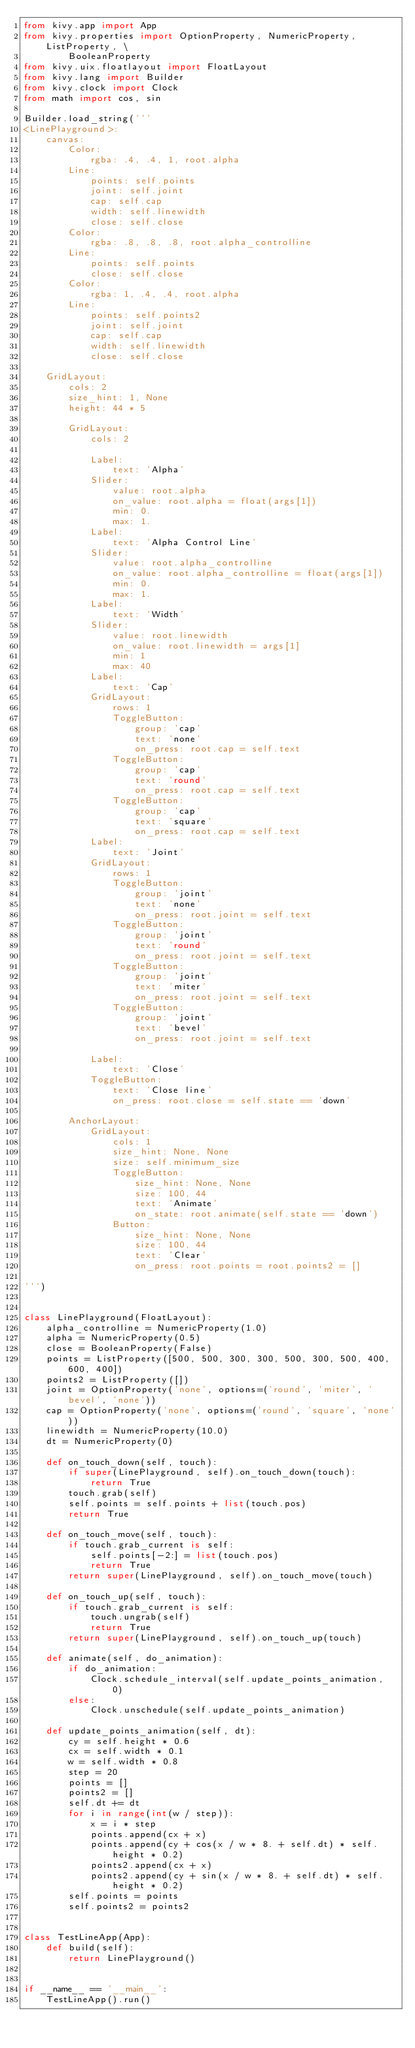<code> <loc_0><loc_0><loc_500><loc_500><_Python_>from kivy.app import App
from kivy.properties import OptionProperty, NumericProperty, ListProperty, \
        BooleanProperty
from kivy.uix.floatlayout import FloatLayout
from kivy.lang import Builder
from kivy.clock import Clock
from math import cos, sin

Builder.load_string('''
<LinePlayground>:
    canvas:
        Color:
            rgba: .4, .4, 1, root.alpha
        Line:
            points: self.points
            joint: self.joint
            cap: self.cap
            width: self.linewidth
            close: self.close
        Color:
            rgba: .8, .8, .8, root.alpha_controlline
        Line:
            points: self.points
            close: self.close
        Color:
            rgba: 1, .4, .4, root.alpha
        Line:
            points: self.points2
            joint: self.joint
            cap: self.cap
            width: self.linewidth
            close: self.close

    GridLayout:
        cols: 2
        size_hint: 1, None
        height: 44 * 5

        GridLayout:
            cols: 2

            Label:
                text: 'Alpha'
            Slider:
                value: root.alpha
                on_value: root.alpha = float(args[1])
                min: 0.
                max: 1.
            Label:
                text: 'Alpha Control Line'
            Slider:
                value: root.alpha_controlline
                on_value: root.alpha_controlline = float(args[1])
                min: 0.
                max: 1.
            Label:
                text: 'Width'
            Slider:
                value: root.linewidth
                on_value: root.linewidth = args[1]
                min: 1
                max: 40
            Label:
                text: 'Cap'
            GridLayout:
                rows: 1
                ToggleButton:
                    group: 'cap'
                    text: 'none'
                    on_press: root.cap = self.text
                ToggleButton:
                    group: 'cap'
                    text: 'round'
                    on_press: root.cap = self.text
                ToggleButton:
                    group: 'cap'
                    text: 'square'
                    on_press: root.cap = self.text
            Label:
                text: 'Joint'
            GridLayout:
                rows: 1
                ToggleButton:
                    group: 'joint'
                    text: 'none'
                    on_press: root.joint = self.text
                ToggleButton:
                    group: 'joint'
                    text: 'round'
                    on_press: root.joint = self.text
                ToggleButton:
                    group: 'joint'
                    text: 'miter'
                    on_press: root.joint = self.text
                ToggleButton:
                    group: 'joint'
                    text: 'bevel'
                    on_press: root.joint = self.text

            Label:
                text: 'Close'
            ToggleButton:
                text: 'Close line'
                on_press: root.close = self.state == 'down'

        AnchorLayout:
            GridLayout:
                cols: 1
                size_hint: None, None
                size: self.minimum_size
                ToggleButton:
                    size_hint: None, None
                    size: 100, 44
                    text: 'Animate'
                    on_state: root.animate(self.state == 'down')
                Button:
                    size_hint: None, None
                    size: 100, 44
                    text: 'Clear'
                    on_press: root.points = root.points2 = []

''')


class LinePlayground(FloatLayout):
    alpha_controlline = NumericProperty(1.0)
    alpha = NumericProperty(0.5)
    close = BooleanProperty(False)
    points = ListProperty([500, 500, 300, 300, 500, 300, 500, 400, 600, 400])
    points2 = ListProperty([])
    joint = OptionProperty('none', options=('round', 'miter', 'bevel', 'none'))
    cap = OptionProperty('none', options=('round', 'square', 'none'))
    linewidth = NumericProperty(10.0)
    dt = NumericProperty(0)

    def on_touch_down(self, touch):
        if super(LinePlayground, self).on_touch_down(touch):
            return True
        touch.grab(self)
        self.points = self.points + list(touch.pos)
        return True

    def on_touch_move(self, touch):
        if touch.grab_current is self:
            self.points[-2:] = list(touch.pos)
            return True
        return super(LinePlayground, self).on_touch_move(touch)

    def on_touch_up(self, touch):
        if touch.grab_current is self:
            touch.ungrab(self)
            return True
        return super(LinePlayground, self).on_touch_up(touch)

    def animate(self, do_animation):
        if do_animation:
            Clock.schedule_interval(self.update_points_animation, 0)
        else:
            Clock.unschedule(self.update_points_animation)

    def update_points_animation(self, dt):
        cy = self.height * 0.6
        cx = self.width * 0.1
        w = self.width * 0.8
        step = 20
        points = []
        points2 = []
        self.dt += dt
        for i in range(int(w / step)):
            x = i * step
            points.append(cx + x)
            points.append(cy + cos(x / w * 8. + self.dt) * self.height * 0.2)
            points2.append(cx + x)
            points2.append(cy + sin(x / w * 8. + self.dt) * self.height * 0.2)
        self.points = points
        self.points2 = points2


class TestLineApp(App):
    def build(self):
        return LinePlayground()


if __name__ == '__main__':
    TestLineApp().run()
</code> 